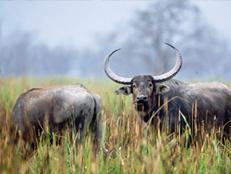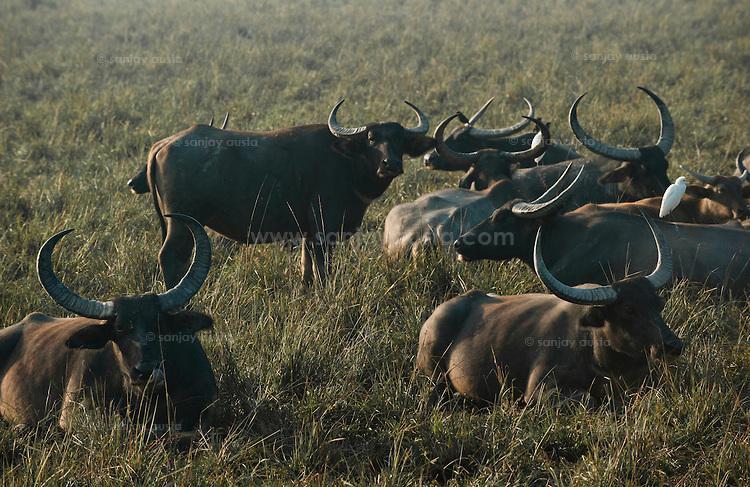The first image is the image on the left, the second image is the image on the right. Examine the images to the left and right. Is the description "There are 3 water buffalos shown." accurate? Answer yes or no. No. 